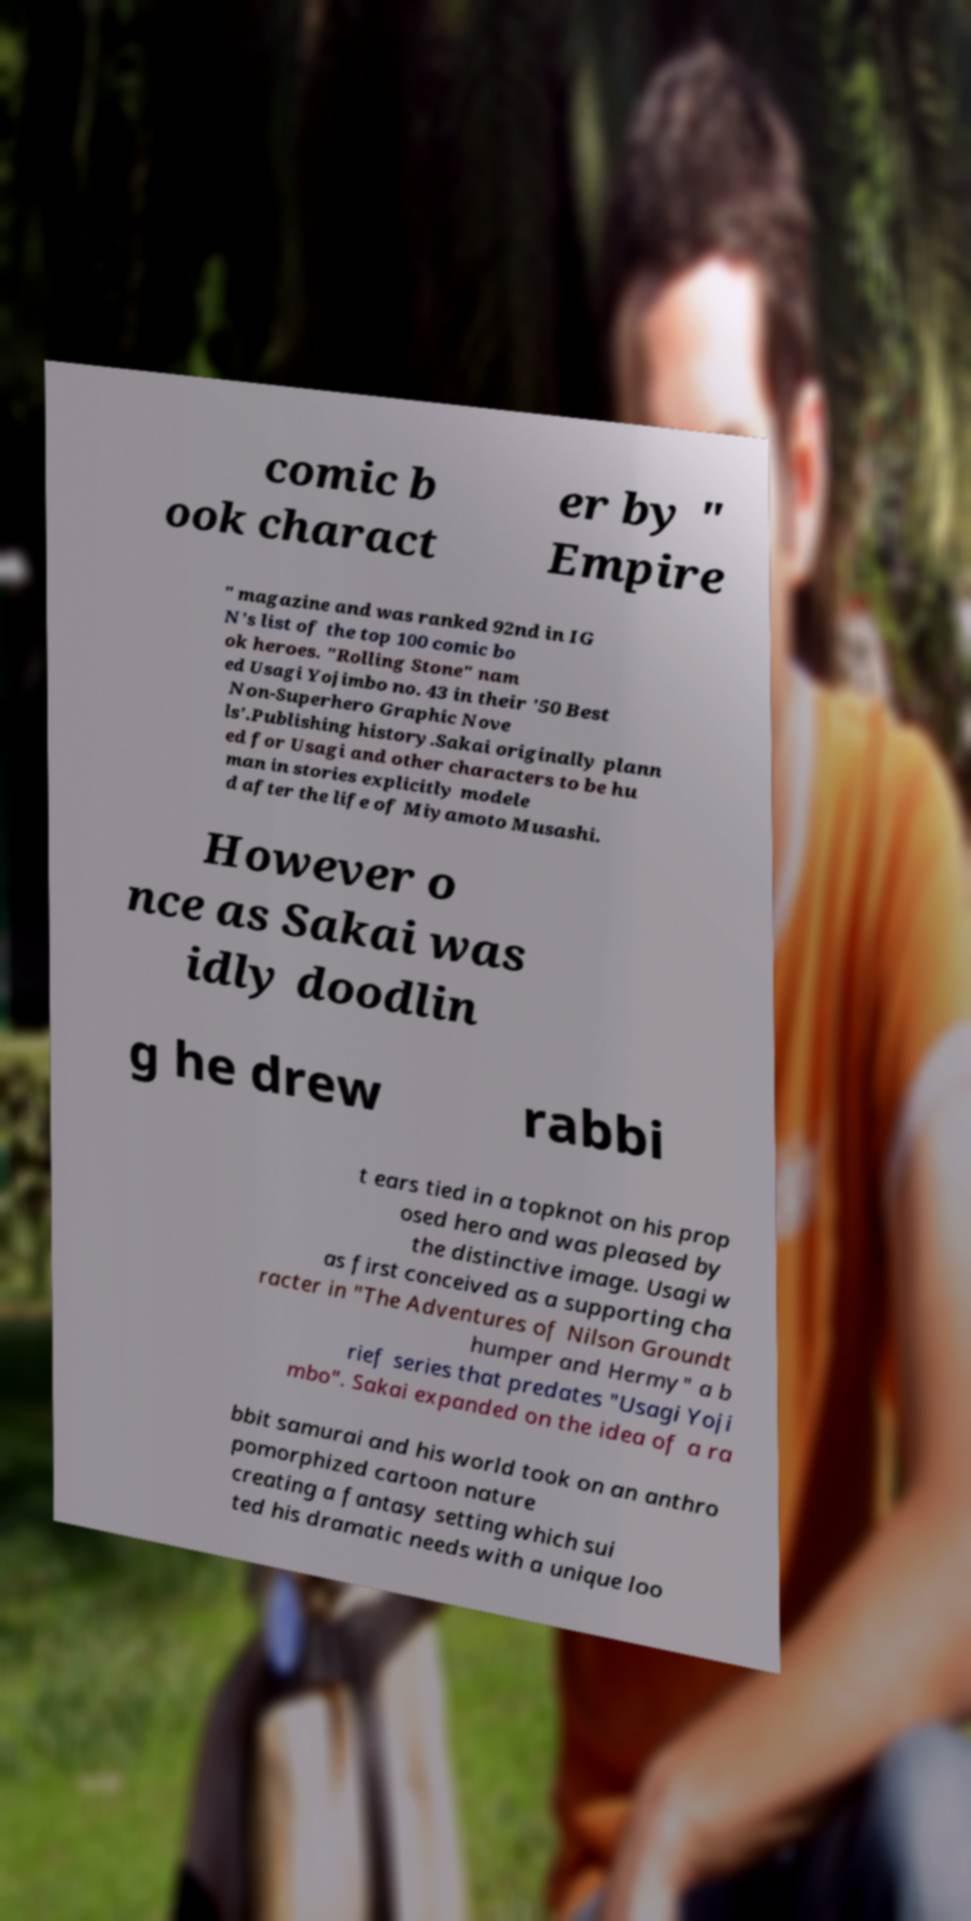There's text embedded in this image that I need extracted. Can you transcribe it verbatim? comic b ook charact er by " Empire " magazine and was ranked 92nd in IG N's list of the top 100 comic bo ok heroes. "Rolling Stone" nam ed Usagi Yojimbo no. 43 in their '50 Best Non-Superhero Graphic Nove ls'.Publishing history.Sakai originally plann ed for Usagi and other characters to be hu man in stories explicitly modele d after the life of Miyamoto Musashi. However o nce as Sakai was idly doodlin g he drew rabbi t ears tied in a topknot on his prop osed hero and was pleased by the distinctive image. Usagi w as first conceived as a supporting cha racter in "The Adventures of Nilson Groundt humper and Hermy" a b rief series that predates "Usagi Yoji mbo". Sakai expanded on the idea of a ra bbit samurai and his world took on an anthro pomorphized cartoon nature creating a fantasy setting which sui ted his dramatic needs with a unique loo 